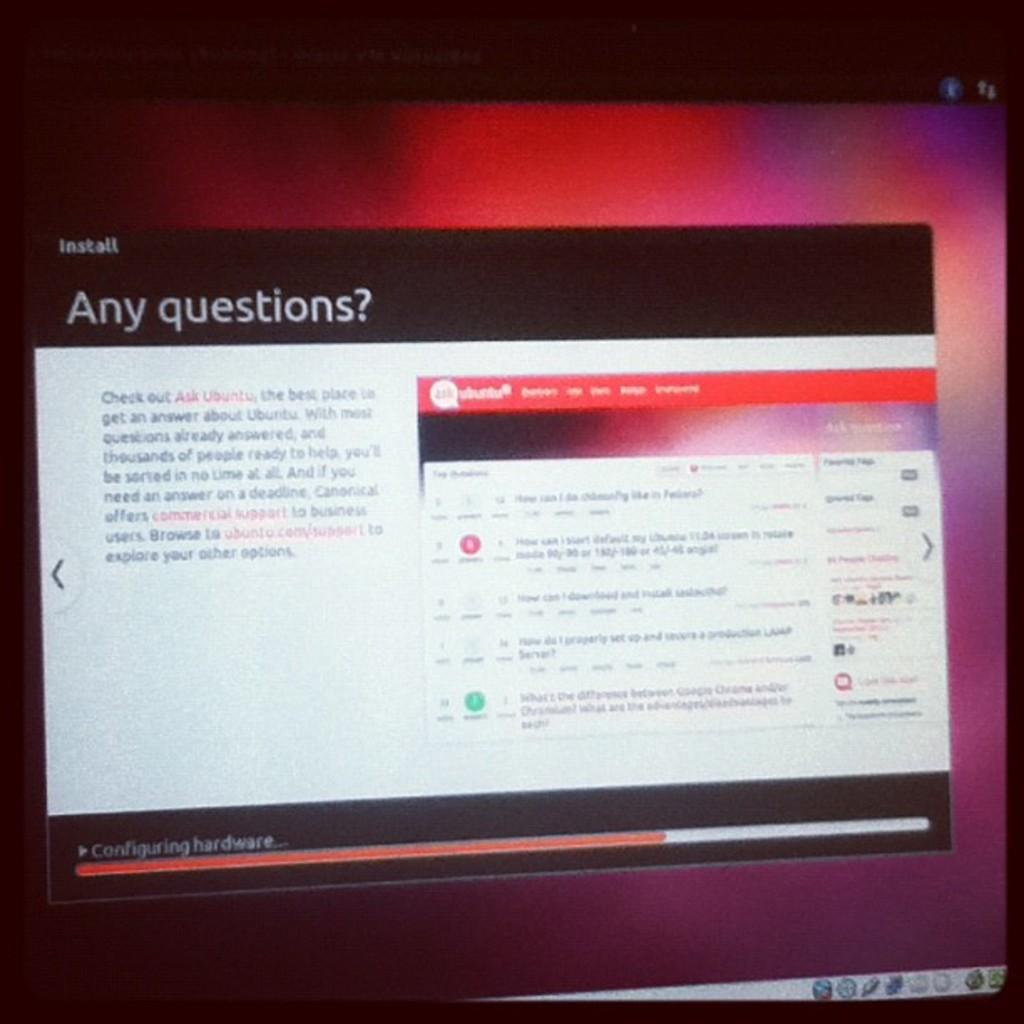What is the source of the image? The image is taken from a desktop monitor. What is displayed on the monitor? There is a popup screen on the monitor. How many pickles are visible on the desktop monitor in the image? There are no pickles visible on the desktop monitor in the image. What type of plane is flying in the background of the image? There is no plane visible in the image; it only shows a desktop monitor with a popup screen. 